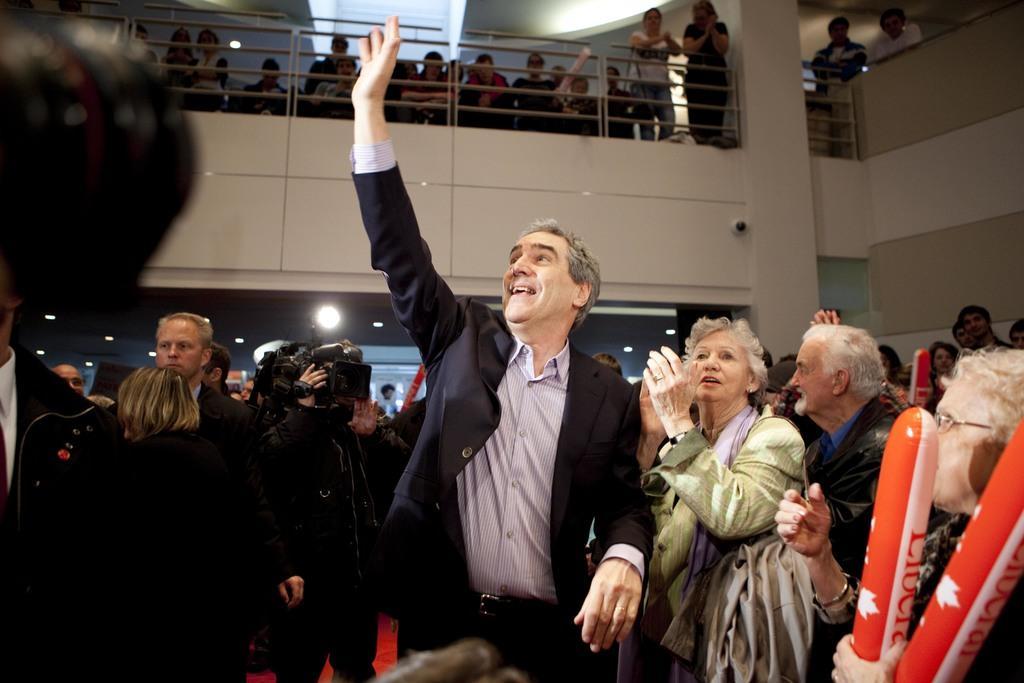Could you give a brief overview of what you see in this image? Here in this, in the front we can see number of people standing on the and all of them are cheering and the person in the front is wearing coat and waving his hand and smiling and above him we can see number of people standing on the floor and in front of them we can see a railing present and we can also see lights present on the roof and we can see a person capturing the moments with a video camera in his hands and the woman beside him is clapping. 